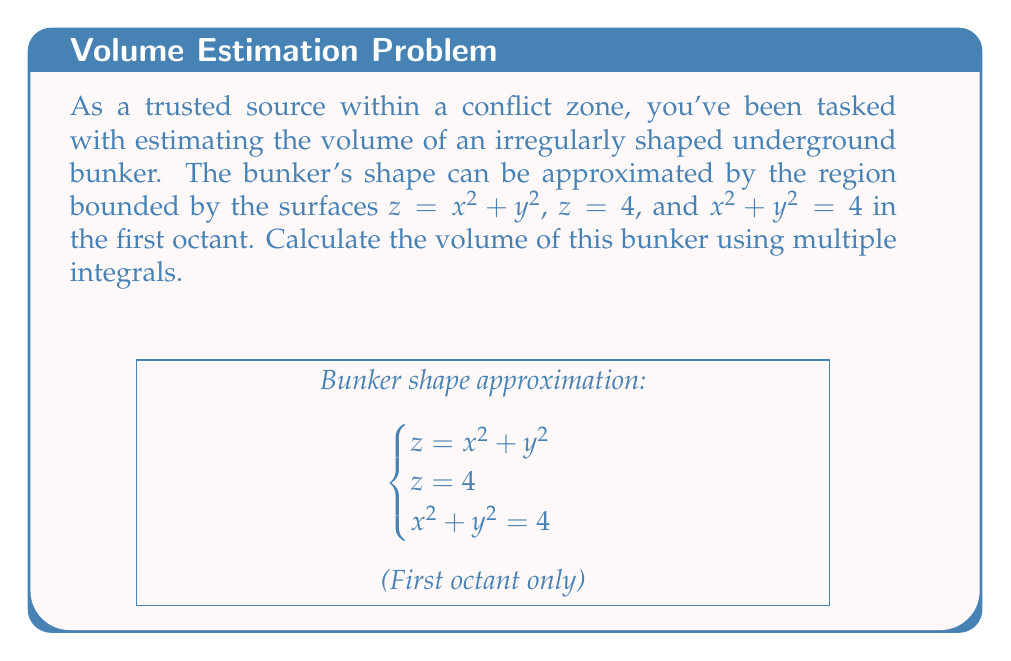Can you solve this math problem? To compute the volume of this irregular shape, we'll use a triple integral in cylindrical coordinates. Here's the step-by-step solution:

1) First, we identify the bounds of our integration:
   - Radially (r): From 0 to 2 (as $x^2 + y^2 = 4$ implies $r = 2$)
   - Angularly (θ): From 0 to π/2 (first quadrant in xy-plane)
   - Vertically (z): From $r^2$ to 4 (lower surface is $z = x^2 + y^2 = r^2$, upper is $z = 4$)

2) Set up the triple integral:
   $$V = \int_0^{\pi/2} \int_0^2 \int_{r^2}^4 r \, dz \, dr \, d\theta$$

3) Evaluate the innermost integral (with respect to z):
   $$V = \int_0^{\pi/2} \int_0^2 r(4 - r^2) \, dr \, d\theta$$

4) Evaluate the integral with respect to r:
   $$V = \int_0^{\pi/2} \left[2r^2 - \frac{r^4}{4}\right]_0^2 \, d\theta$$
   $$= \int_0^{\pi/2} \left(8 - 4\right) \, d\theta = \int_0^{\pi/2} 4 \, d\theta$$

5) Finally, evaluate the outermost integral:
   $$V = 4 \left[\theta\right]_0^{\pi/2} = 4 \cdot \frac{\pi}{2} = 2\pi$$

Therefore, the volume of the bunker is $2\pi$ cubic units.
Answer: $2\pi$ cubic units 